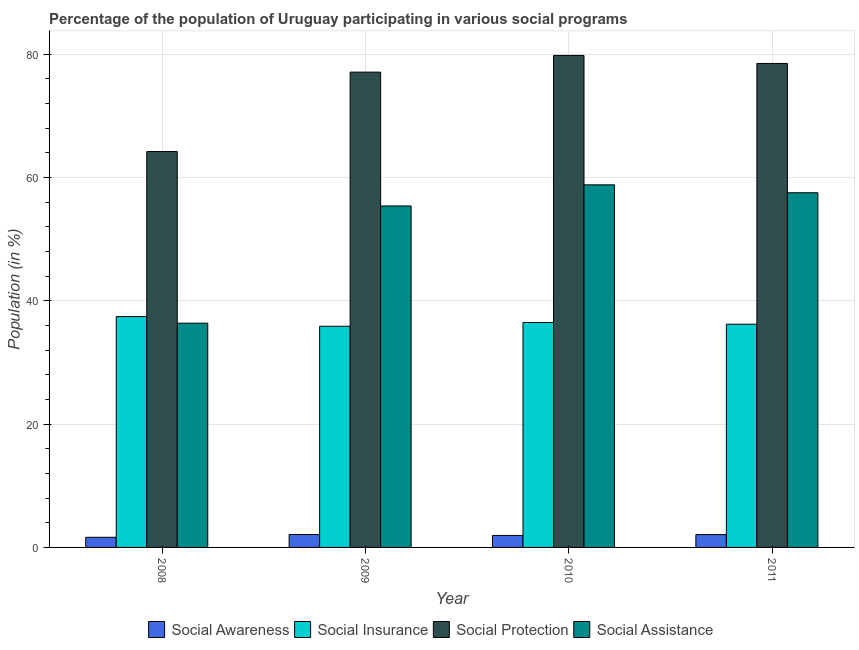How many groups of bars are there?
Offer a terse response. 4. Are the number of bars per tick equal to the number of legend labels?
Your answer should be compact. Yes. Are the number of bars on each tick of the X-axis equal?
Make the answer very short. Yes. How many bars are there on the 3rd tick from the left?
Provide a short and direct response. 4. How many bars are there on the 3rd tick from the right?
Make the answer very short. 4. In how many cases, is the number of bars for a given year not equal to the number of legend labels?
Offer a terse response. 0. What is the participation of population in social insurance programs in 2008?
Provide a short and direct response. 37.44. Across all years, what is the maximum participation of population in social protection programs?
Keep it short and to the point. 79.78. Across all years, what is the minimum participation of population in social protection programs?
Offer a terse response. 64.19. In which year was the participation of population in social insurance programs maximum?
Your answer should be very brief. 2008. What is the total participation of population in social protection programs in the graph?
Provide a short and direct response. 299.51. What is the difference between the participation of population in social awareness programs in 2008 and that in 2010?
Keep it short and to the point. -0.3. What is the difference between the participation of population in social insurance programs in 2008 and the participation of population in social protection programs in 2009?
Ensure brevity in your answer.  1.57. What is the average participation of population in social assistance programs per year?
Your answer should be compact. 52.01. In how many years, is the participation of population in social assistance programs greater than 36 %?
Offer a very short reply. 4. What is the ratio of the participation of population in social assistance programs in 2008 to that in 2010?
Your answer should be compact. 0.62. Is the difference between the participation of population in social assistance programs in 2008 and 2011 greater than the difference between the participation of population in social insurance programs in 2008 and 2011?
Provide a short and direct response. No. What is the difference between the highest and the second highest participation of population in social protection programs?
Provide a short and direct response. 1.3. What is the difference between the highest and the lowest participation of population in social assistance programs?
Offer a very short reply. 22.43. Is the sum of the participation of population in social awareness programs in 2008 and 2009 greater than the maximum participation of population in social assistance programs across all years?
Offer a terse response. Yes. Is it the case that in every year, the sum of the participation of population in social awareness programs and participation of population in social insurance programs is greater than the sum of participation of population in social protection programs and participation of population in social assistance programs?
Provide a succinct answer. No. What does the 1st bar from the left in 2008 represents?
Provide a short and direct response. Social Awareness. What does the 4th bar from the right in 2010 represents?
Offer a terse response. Social Awareness. How many bars are there?
Provide a short and direct response. 16. Are all the bars in the graph horizontal?
Your response must be concise. No. Are the values on the major ticks of Y-axis written in scientific E-notation?
Ensure brevity in your answer.  No. Does the graph contain any zero values?
Your answer should be compact. No. Does the graph contain grids?
Your answer should be compact. Yes. Where does the legend appear in the graph?
Your answer should be very brief. Bottom center. How are the legend labels stacked?
Provide a succinct answer. Horizontal. What is the title of the graph?
Provide a short and direct response. Percentage of the population of Uruguay participating in various social programs . Does "Bird species" appear as one of the legend labels in the graph?
Offer a terse response. No. What is the label or title of the Y-axis?
Provide a short and direct response. Population (in %). What is the Population (in %) of Social Awareness in 2008?
Keep it short and to the point. 1.65. What is the Population (in %) of Social Insurance in 2008?
Make the answer very short. 37.44. What is the Population (in %) in Social Protection in 2008?
Your answer should be compact. 64.19. What is the Population (in %) in Social Assistance in 2008?
Make the answer very short. 36.36. What is the Population (in %) in Social Awareness in 2009?
Ensure brevity in your answer.  2.1. What is the Population (in %) in Social Insurance in 2009?
Make the answer very short. 35.86. What is the Population (in %) in Social Protection in 2009?
Your answer should be compact. 77.07. What is the Population (in %) in Social Assistance in 2009?
Your answer should be very brief. 55.37. What is the Population (in %) in Social Awareness in 2010?
Your answer should be very brief. 1.95. What is the Population (in %) of Social Insurance in 2010?
Your answer should be compact. 36.47. What is the Population (in %) in Social Protection in 2010?
Keep it short and to the point. 79.78. What is the Population (in %) of Social Assistance in 2010?
Your response must be concise. 58.79. What is the Population (in %) of Social Awareness in 2011?
Your response must be concise. 2.08. What is the Population (in %) of Social Insurance in 2011?
Your answer should be compact. 36.19. What is the Population (in %) in Social Protection in 2011?
Ensure brevity in your answer.  78.48. What is the Population (in %) in Social Assistance in 2011?
Make the answer very short. 57.51. Across all years, what is the maximum Population (in %) of Social Awareness?
Offer a very short reply. 2.1. Across all years, what is the maximum Population (in %) in Social Insurance?
Keep it short and to the point. 37.44. Across all years, what is the maximum Population (in %) of Social Protection?
Your response must be concise. 79.78. Across all years, what is the maximum Population (in %) of Social Assistance?
Your response must be concise. 58.79. Across all years, what is the minimum Population (in %) in Social Awareness?
Make the answer very short. 1.65. Across all years, what is the minimum Population (in %) of Social Insurance?
Give a very brief answer. 35.86. Across all years, what is the minimum Population (in %) in Social Protection?
Provide a succinct answer. 64.19. Across all years, what is the minimum Population (in %) in Social Assistance?
Provide a succinct answer. 36.36. What is the total Population (in %) of Social Awareness in the graph?
Your response must be concise. 7.77. What is the total Population (in %) of Social Insurance in the graph?
Your answer should be very brief. 145.96. What is the total Population (in %) of Social Protection in the graph?
Your response must be concise. 299.51. What is the total Population (in %) in Social Assistance in the graph?
Keep it short and to the point. 208.03. What is the difference between the Population (in %) in Social Awareness in 2008 and that in 2009?
Give a very brief answer. -0.45. What is the difference between the Population (in %) of Social Insurance in 2008 and that in 2009?
Your answer should be compact. 1.57. What is the difference between the Population (in %) in Social Protection in 2008 and that in 2009?
Your answer should be very brief. -12.88. What is the difference between the Population (in %) in Social Assistance in 2008 and that in 2009?
Offer a very short reply. -19.01. What is the difference between the Population (in %) of Social Awareness in 2008 and that in 2010?
Keep it short and to the point. -0.3. What is the difference between the Population (in %) in Social Insurance in 2008 and that in 2010?
Make the answer very short. 0.97. What is the difference between the Population (in %) in Social Protection in 2008 and that in 2010?
Offer a terse response. -15.59. What is the difference between the Population (in %) of Social Assistance in 2008 and that in 2010?
Your response must be concise. -22.43. What is the difference between the Population (in %) in Social Awareness in 2008 and that in 2011?
Provide a short and direct response. -0.43. What is the difference between the Population (in %) of Social Insurance in 2008 and that in 2011?
Your response must be concise. 1.24. What is the difference between the Population (in %) in Social Protection in 2008 and that in 2011?
Keep it short and to the point. -14.29. What is the difference between the Population (in %) in Social Assistance in 2008 and that in 2011?
Provide a short and direct response. -21.15. What is the difference between the Population (in %) of Social Awareness in 2009 and that in 2010?
Provide a short and direct response. 0.15. What is the difference between the Population (in %) of Social Insurance in 2009 and that in 2010?
Ensure brevity in your answer.  -0.6. What is the difference between the Population (in %) in Social Protection in 2009 and that in 2010?
Ensure brevity in your answer.  -2.71. What is the difference between the Population (in %) in Social Assistance in 2009 and that in 2010?
Your response must be concise. -3.42. What is the difference between the Population (in %) of Social Awareness in 2009 and that in 2011?
Your response must be concise. 0.01. What is the difference between the Population (in %) in Social Insurance in 2009 and that in 2011?
Give a very brief answer. -0.33. What is the difference between the Population (in %) of Social Protection in 2009 and that in 2011?
Your answer should be very brief. -1.41. What is the difference between the Population (in %) of Social Assistance in 2009 and that in 2011?
Keep it short and to the point. -2.14. What is the difference between the Population (in %) of Social Awareness in 2010 and that in 2011?
Give a very brief answer. -0.14. What is the difference between the Population (in %) in Social Insurance in 2010 and that in 2011?
Give a very brief answer. 0.27. What is the difference between the Population (in %) in Social Protection in 2010 and that in 2011?
Provide a succinct answer. 1.3. What is the difference between the Population (in %) of Social Assistance in 2010 and that in 2011?
Ensure brevity in your answer.  1.28. What is the difference between the Population (in %) in Social Awareness in 2008 and the Population (in %) in Social Insurance in 2009?
Your answer should be compact. -34.22. What is the difference between the Population (in %) in Social Awareness in 2008 and the Population (in %) in Social Protection in 2009?
Your answer should be compact. -75.42. What is the difference between the Population (in %) of Social Awareness in 2008 and the Population (in %) of Social Assistance in 2009?
Your response must be concise. -53.72. What is the difference between the Population (in %) of Social Insurance in 2008 and the Population (in %) of Social Protection in 2009?
Provide a short and direct response. -39.63. What is the difference between the Population (in %) in Social Insurance in 2008 and the Population (in %) in Social Assistance in 2009?
Provide a succinct answer. -17.93. What is the difference between the Population (in %) in Social Protection in 2008 and the Population (in %) in Social Assistance in 2009?
Provide a short and direct response. 8.82. What is the difference between the Population (in %) of Social Awareness in 2008 and the Population (in %) of Social Insurance in 2010?
Your response must be concise. -34.82. What is the difference between the Population (in %) of Social Awareness in 2008 and the Population (in %) of Social Protection in 2010?
Provide a short and direct response. -78.13. What is the difference between the Population (in %) of Social Awareness in 2008 and the Population (in %) of Social Assistance in 2010?
Offer a very short reply. -57.14. What is the difference between the Population (in %) of Social Insurance in 2008 and the Population (in %) of Social Protection in 2010?
Your answer should be very brief. -42.34. What is the difference between the Population (in %) in Social Insurance in 2008 and the Population (in %) in Social Assistance in 2010?
Provide a short and direct response. -21.35. What is the difference between the Population (in %) of Social Protection in 2008 and the Population (in %) of Social Assistance in 2010?
Provide a short and direct response. 5.4. What is the difference between the Population (in %) of Social Awareness in 2008 and the Population (in %) of Social Insurance in 2011?
Ensure brevity in your answer.  -34.55. What is the difference between the Population (in %) in Social Awareness in 2008 and the Population (in %) in Social Protection in 2011?
Make the answer very short. -76.83. What is the difference between the Population (in %) in Social Awareness in 2008 and the Population (in %) in Social Assistance in 2011?
Ensure brevity in your answer.  -55.86. What is the difference between the Population (in %) in Social Insurance in 2008 and the Population (in %) in Social Protection in 2011?
Your answer should be compact. -41.04. What is the difference between the Population (in %) in Social Insurance in 2008 and the Population (in %) in Social Assistance in 2011?
Your answer should be compact. -20.07. What is the difference between the Population (in %) of Social Protection in 2008 and the Population (in %) of Social Assistance in 2011?
Ensure brevity in your answer.  6.68. What is the difference between the Population (in %) in Social Awareness in 2009 and the Population (in %) in Social Insurance in 2010?
Offer a terse response. -34.37. What is the difference between the Population (in %) of Social Awareness in 2009 and the Population (in %) of Social Protection in 2010?
Provide a succinct answer. -77.68. What is the difference between the Population (in %) in Social Awareness in 2009 and the Population (in %) in Social Assistance in 2010?
Provide a succinct answer. -56.7. What is the difference between the Population (in %) of Social Insurance in 2009 and the Population (in %) of Social Protection in 2010?
Give a very brief answer. -43.91. What is the difference between the Population (in %) in Social Insurance in 2009 and the Population (in %) in Social Assistance in 2010?
Provide a short and direct response. -22.93. What is the difference between the Population (in %) of Social Protection in 2009 and the Population (in %) of Social Assistance in 2010?
Give a very brief answer. 18.27. What is the difference between the Population (in %) in Social Awareness in 2009 and the Population (in %) in Social Insurance in 2011?
Your answer should be compact. -34.1. What is the difference between the Population (in %) of Social Awareness in 2009 and the Population (in %) of Social Protection in 2011?
Ensure brevity in your answer.  -76.38. What is the difference between the Population (in %) of Social Awareness in 2009 and the Population (in %) of Social Assistance in 2011?
Make the answer very short. -55.41. What is the difference between the Population (in %) in Social Insurance in 2009 and the Population (in %) in Social Protection in 2011?
Provide a succinct answer. -42.61. What is the difference between the Population (in %) in Social Insurance in 2009 and the Population (in %) in Social Assistance in 2011?
Give a very brief answer. -21.64. What is the difference between the Population (in %) of Social Protection in 2009 and the Population (in %) of Social Assistance in 2011?
Keep it short and to the point. 19.56. What is the difference between the Population (in %) in Social Awareness in 2010 and the Population (in %) in Social Insurance in 2011?
Make the answer very short. -34.25. What is the difference between the Population (in %) in Social Awareness in 2010 and the Population (in %) in Social Protection in 2011?
Keep it short and to the point. -76.53. What is the difference between the Population (in %) in Social Awareness in 2010 and the Population (in %) in Social Assistance in 2011?
Provide a succinct answer. -55.56. What is the difference between the Population (in %) of Social Insurance in 2010 and the Population (in %) of Social Protection in 2011?
Give a very brief answer. -42.01. What is the difference between the Population (in %) of Social Insurance in 2010 and the Population (in %) of Social Assistance in 2011?
Keep it short and to the point. -21.04. What is the difference between the Population (in %) in Social Protection in 2010 and the Population (in %) in Social Assistance in 2011?
Provide a succinct answer. 22.27. What is the average Population (in %) of Social Awareness per year?
Provide a succinct answer. 1.94. What is the average Population (in %) in Social Insurance per year?
Ensure brevity in your answer.  36.49. What is the average Population (in %) in Social Protection per year?
Offer a very short reply. 74.88. What is the average Population (in %) in Social Assistance per year?
Provide a succinct answer. 52.01. In the year 2008, what is the difference between the Population (in %) of Social Awareness and Population (in %) of Social Insurance?
Offer a terse response. -35.79. In the year 2008, what is the difference between the Population (in %) in Social Awareness and Population (in %) in Social Protection?
Keep it short and to the point. -62.54. In the year 2008, what is the difference between the Population (in %) of Social Awareness and Population (in %) of Social Assistance?
Offer a very short reply. -34.71. In the year 2008, what is the difference between the Population (in %) in Social Insurance and Population (in %) in Social Protection?
Offer a terse response. -26.75. In the year 2008, what is the difference between the Population (in %) of Social Insurance and Population (in %) of Social Assistance?
Your answer should be very brief. 1.08. In the year 2008, what is the difference between the Population (in %) of Social Protection and Population (in %) of Social Assistance?
Offer a terse response. 27.83. In the year 2009, what is the difference between the Population (in %) of Social Awareness and Population (in %) of Social Insurance?
Give a very brief answer. -33.77. In the year 2009, what is the difference between the Population (in %) in Social Awareness and Population (in %) in Social Protection?
Make the answer very short. -74.97. In the year 2009, what is the difference between the Population (in %) in Social Awareness and Population (in %) in Social Assistance?
Your answer should be compact. -53.27. In the year 2009, what is the difference between the Population (in %) in Social Insurance and Population (in %) in Social Protection?
Your answer should be very brief. -41.2. In the year 2009, what is the difference between the Population (in %) in Social Insurance and Population (in %) in Social Assistance?
Your answer should be very brief. -19.5. In the year 2009, what is the difference between the Population (in %) of Social Protection and Population (in %) of Social Assistance?
Ensure brevity in your answer.  21.7. In the year 2010, what is the difference between the Population (in %) in Social Awareness and Population (in %) in Social Insurance?
Keep it short and to the point. -34.52. In the year 2010, what is the difference between the Population (in %) of Social Awareness and Population (in %) of Social Protection?
Ensure brevity in your answer.  -77.83. In the year 2010, what is the difference between the Population (in %) of Social Awareness and Population (in %) of Social Assistance?
Ensure brevity in your answer.  -56.85. In the year 2010, what is the difference between the Population (in %) of Social Insurance and Population (in %) of Social Protection?
Give a very brief answer. -43.31. In the year 2010, what is the difference between the Population (in %) in Social Insurance and Population (in %) in Social Assistance?
Offer a terse response. -22.32. In the year 2010, what is the difference between the Population (in %) of Social Protection and Population (in %) of Social Assistance?
Give a very brief answer. 20.98. In the year 2011, what is the difference between the Population (in %) in Social Awareness and Population (in %) in Social Insurance?
Your answer should be very brief. -34.11. In the year 2011, what is the difference between the Population (in %) of Social Awareness and Population (in %) of Social Protection?
Provide a short and direct response. -76.4. In the year 2011, what is the difference between the Population (in %) of Social Awareness and Population (in %) of Social Assistance?
Ensure brevity in your answer.  -55.43. In the year 2011, what is the difference between the Population (in %) of Social Insurance and Population (in %) of Social Protection?
Offer a very short reply. -42.28. In the year 2011, what is the difference between the Population (in %) of Social Insurance and Population (in %) of Social Assistance?
Your answer should be very brief. -21.31. In the year 2011, what is the difference between the Population (in %) in Social Protection and Population (in %) in Social Assistance?
Offer a terse response. 20.97. What is the ratio of the Population (in %) of Social Awareness in 2008 to that in 2009?
Offer a terse response. 0.79. What is the ratio of the Population (in %) of Social Insurance in 2008 to that in 2009?
Provide a short and direct response. 1.04. What is the ratio of the Population (in %) in Social Protection in 2008 to that in 2009?
Your answer should be compact. 0.83. What is the ratio of the Population (in %) of Social Assistance in 2008 to that in 2009?
Ensure brevity in your answer.  0.66. What is the ratio of the Population (in %) of Social Awareness in 2008 to that in 2010?
Provide a succinct answer. 0.85. What is the ratio of the Population (in %) in Social Insurance in 2008 to that in 2010?
Your answer should be compact. 1.03. What is the ratio of the Population (in %) in Social Protection in 2008 to that in 2010?
Your answer should be very brief. 0.8. What is the ratio of the Population (in %) of Social Assistance in 2008 to that in 2010?
Offer a very short reply. 0.62. What is the ratio of the Population (in %) in Social Awareness in 2008 to that in 2011?
Your answer should be very brief. 0.79. What is the ratio of the Population (in %) of Social Insurance in 2008 to that in 2011?
Keep it short and to the point. 1.03. What is the ratio of the Population (in %) of Social Protection in 2008 to that in 2011?
Provide a short and direct response. 0.82. What is the ratio of the Population (in %) of Social Assistance in 2008 to that in 2011?
Offer a terse response. 0.63. What is the ratio of the Population (in %) of Social Awareness in 2009 to that in 2010?
Your answer should be compact. 1.08. What is the ratio of the Population (in %) of Social Insurance in 2009 to that in 2010?
Your response must be concise. 0.98. What is the ratio of the Population (in %) in Social Assistance in 2009 to that in 2010?
Your response must be concise. 0.94. What is the ratio of the Population (in %) of Social Awareness in 2009 to that in 2011?
Provide a succinct answer. 1.01. What is the ratio of the Population (in %) in Social Insurance in 2009 to that in 2011?
Offer a terse response. 0.99. What is the ratio of the Population (in %) of Social Assistance in 2009 to that in 2011?
Keep it short and to the point. 0.96. What is the ratio of the Population (in %) in Social Awareness in 2010 to that in 2011?
Give a very brief answer. 0.94. What is the ratio of the Population (in %) of Social Insurance in 2010 to that in 2011?
Provide a succinct answer. 1.01. What is the ratio of the Population (in %) of Social Protection in 2010 to that in 2011?
Your answer should be compact. 1.02. What is the ratio of the Population (in %) in Social Assistance in 2010 to that in 2011?
Make the answer very short. 1.02. What is the difference between the highest and the second highest Population (in %) in Social Awareness?
Your answer should be compact. 0.01. What is the difference between the highest and the second highest Population (in %) in Social Insurance?
Keep it short and to the point. 0.97. What is the difference between the highest and the second highest Population (in %) in Social Protection?
Your answer should be compact. 1.3. What is the difference between the highest and the second highest Population (in %) of Social Assistance?
Your answer should be very brief. 1.28. What is the difference between the highest and the lowest Population (in %) in Social Awareness?
Your answer should be very brief. 0.45. What is the difference between the highest and the lowest Population (in %) in Social Insurance?
Provide a succinct answer. 1.57. What is the difference between the highest and the lowest Population (in %) of Social Protection?
Ensure brevity in your answer.  15.59. What is the difference between the highest and the lowest Population (in %) of Social Assistance?
Your answer should be compact. 22.43. 